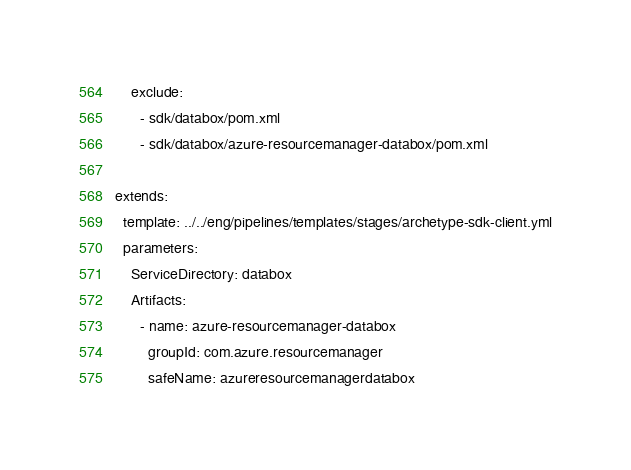<code> <loc_0><loc_0><loc_500><loc_500><_YAML_>    exclude:
      - sdk/databox/pom.xml
      - sdk/databox/azure-resourcemanager-databox/pom.xml

extends:
  template: ../../eng/pipelines/templates/stages/archetype-sdk-client.yml
  parameters:
    ServiceDirectory: databox
    Artifacts:
      - name: azure-resourcemanager-databox
        groupId: com.azure.resourcemanager
        safeName: azureresourcemanagerdatabox
</code> 